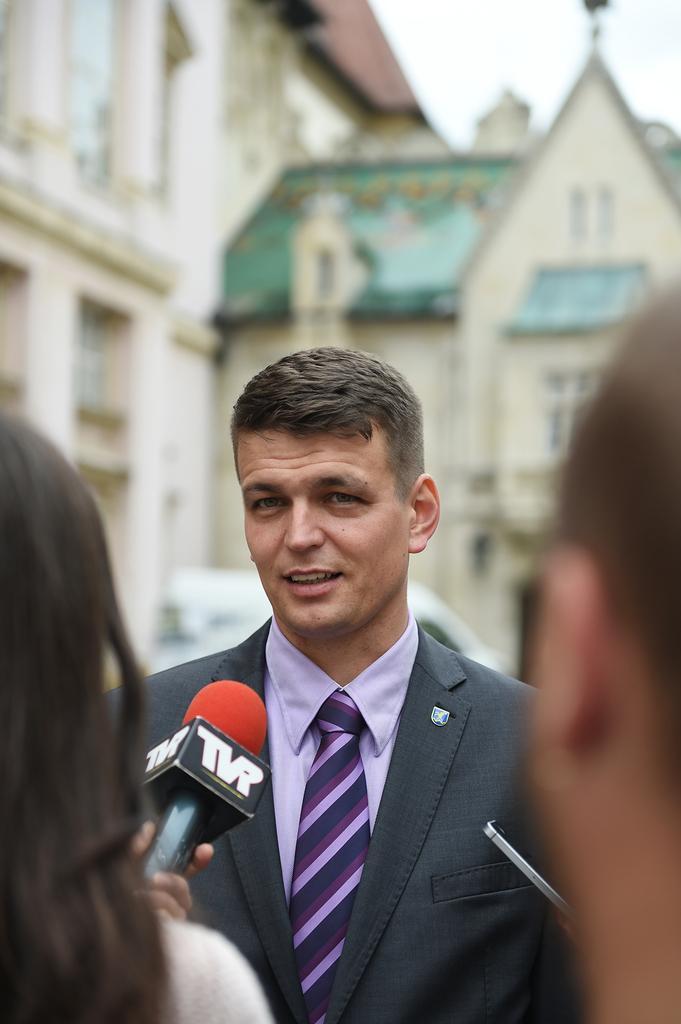In one or two sentences, can you explain what this image depicts? In front of the image there are two persons. On the left side of the image there is a man holding a mic in his hand. Behind the mic there's a man standing. Behind him there is a building with walls, windows and roofs. 